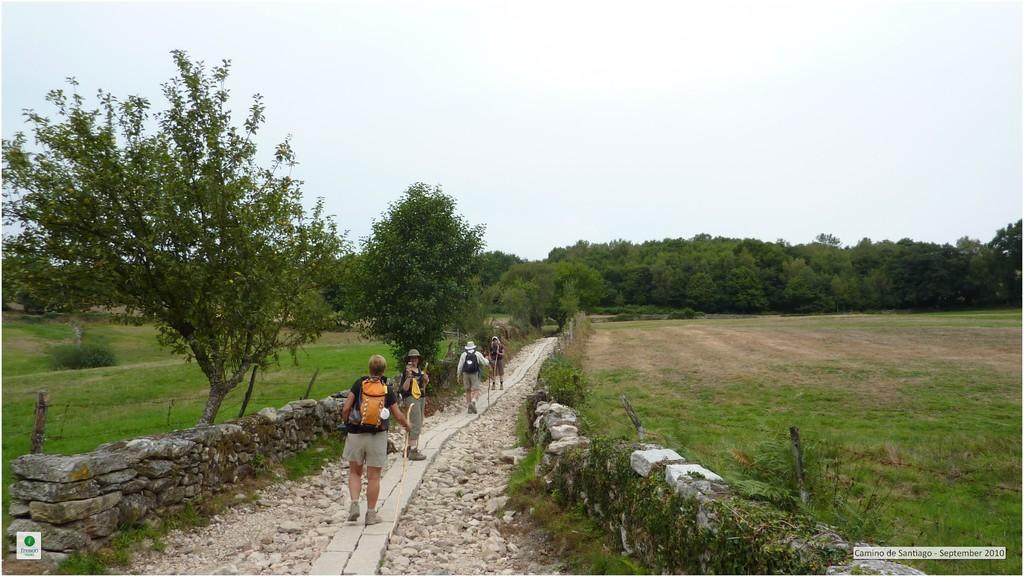What are the people in the image doing? The people in the image are walking. What are the people wearing on their bodies? The people are wearing bags. What objects are the people holding in their hands? The people are holding sticks. What type of vegetation can be seen in the image? There are trees in the image. What architectural feature is present in the image? There is fencing in the image. What type of wall can be seen in the image? There is a brick wall in the image. What is the color of the sky in the image? The sky appears to be white in color. What type of letters can be seen on the quartz in the image? There is no quartz or letters present in the image. What type of stocking is the person wearing on their head in the image? There is no person wearing a stocking on their head in the image. 